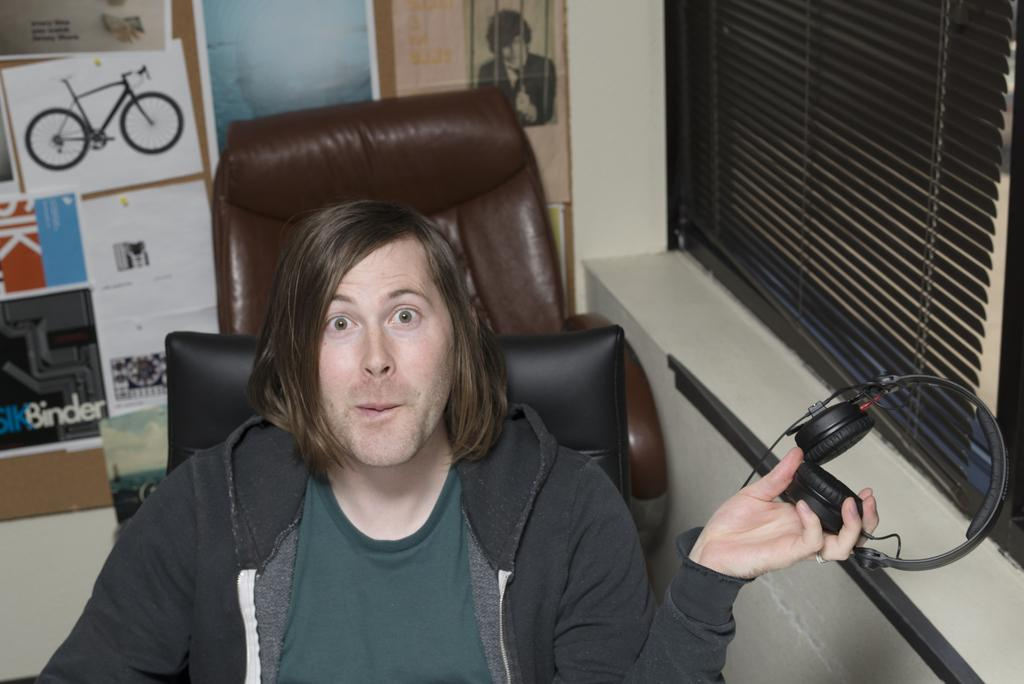What is the man in the image doing? The man is sitting on a chair in the image. What is the man holding in his hand? The man is holding a headset in his hand. What can be seen in the background of the image? There is wallpaper, a board, and a window in the background of the image. What type of pain can be seen on the man's face in the image? There is no indication of pain on the man's face in the image. Is the stew in the image hot or cold? There is no stew present in the image. 